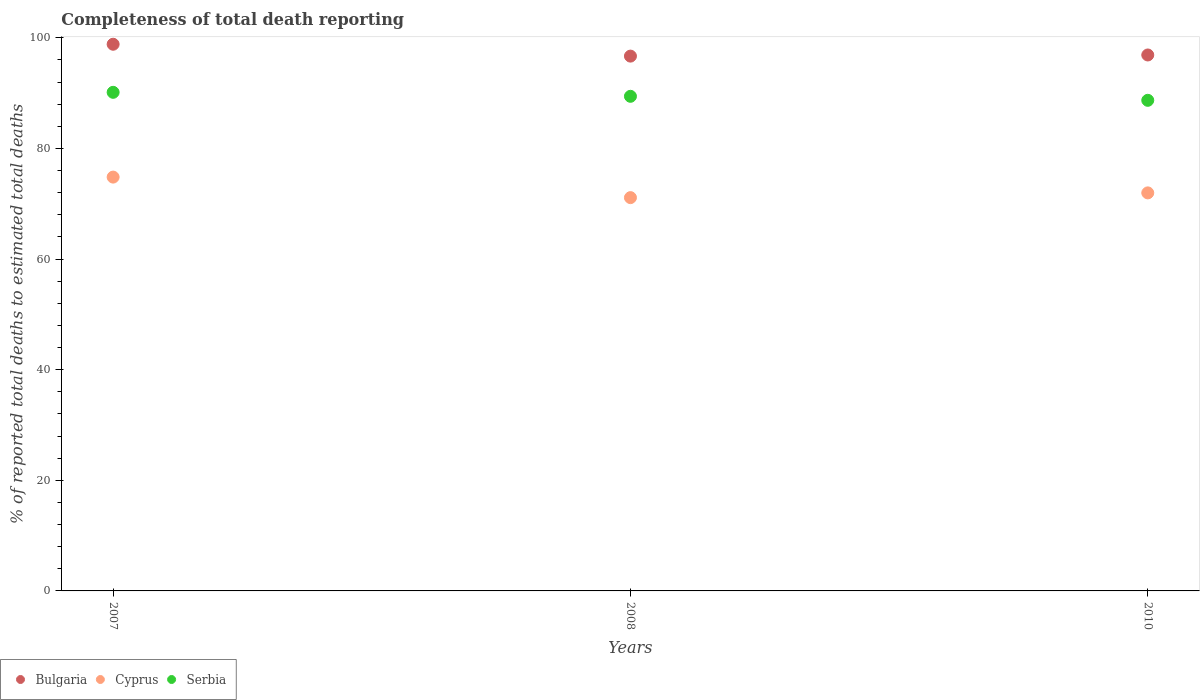What is the percentage of total deaths reported in Bulgaria in 2008?
Provide a succinct answer. 96.7. Across all years, what is the maximum percentage of total deaths reported in Cyprus?
Offer a very short reply. 74.82. Across all years, what is the minimum percentage of total deaths reported in Serbia?
Provide a short and direct response. 88.71. In which year was the percentage of total deaths reported in Bulgaria minimum?
Provide a succinct answer. 2008. What is the total percentage of total deaths reported in Bulgaria in the graph?
Your answer should be very brief. 292.45. What is the difference between the percentage of total deaths reported in Serbia in 2007 and that in 2010?
Your answer should be compact. 1.45. What is the difference between the percentage of total deaths reported in Bulgaria in 2010 and the percentage of total deaths reported in Cyprus in 2008?
Offer a very short reply. 25.79. What is the average percentage of total deaths reported in Serbia per year?
Your response must be concise. 89.43. In the year 2010, what is the difference between the percentage of total deaths reported in Bulgaria and percentage of total deaths reported in Serbia?
Your response must be concise. 8.2. What is the ratio of the percentage of total deaths reported in Bulgaria in 2007 to that in 2008?
Make the answer very short. 1.02. What is the difference between the highest and the second highest percentage of total deaths reported in Serbia?
Offer a very short reply. 0.72. What is the difference between the highest and the lowest percentage of total deaths reported in Cyprus?
Provide a succinct answer. 3.71. In how many years, is the percentage of total deaths reported in Serbia greater than the average percentage of total deaths reported in Serbia taken over all years?
Your answer should be very brief. 2. Is the percentage of total deaths reported in Cyprus strictly greater than the percentage of total deaths reported in Bulgaria over the years?
Ensure brevity in your answer.  No. How many dotlines are there?
Your response must be concise. 3. Does the graph contain any zero values?
Make the answer very short. No. Does the graph contain grids?
Make the answer very short. No. How many legend labels are there?
Your answer should be compact. 3. What is the title of the graph?
Your answer should be compact. Completeness of total death reporting. What is the label or title of the Y-axis?
Offer a very short reply. % of reported total deaths to estimated total deaths. What is the % of reported total deaths to estimated total deaths of Bulgaria in 2007?
Ensure brevity in your answer.  98.84. What is the % of reported total deaths to estimated total deaths in Cyprus in 2007?
Provide a short and direct response. 74.82. What is the % of reported total deaths to estimated total deaths in Serbia in 2007?
Offer a terse response. 90.15. What is the % of reported total deaths to estimated total deaths of Bulgaria in 2008?
Ensure brevity in your answer.  96.7. What is the % of reported total deaths to estimated total deaths in Cyprus in 2008?
Your answer should be very brief. 71.11. What is the % of reported total deaths to estimated total deaths in Serbia in 2008?
Offer a very short reply. 89.43. What is the % of reported total deaths to estimated total deaths in Bulgaria in 2010?
Keep it short and to the point. 96.9. What is the % of reported total deaths to estimated total deaths of Cyprus in 2010?
Offer a very short reply. 71.97. What is the % of reported total deaths to estimated total deaths in Serbia in 2010?
Your answer should be compact. 88.71. Across all years, what is the maximum % of reported total deaths to estimated total deaths in Bulgaria?
Provide a succinct answer. 98.84. Across all years, what is the maximum % of reported total deaths to estimated total deaths of Cyprus?
Provide a succinct answer. 74.82. Across all years, what is the maximum % of reported total deaths to estimated total deaths in Serbia?
Keep it short and to the point. 90.15. Across all years, what is the minimum % of reported total deaths to estimated total deaths in Bulgaria?
Offer a very short reply. 96.7. Across all years, what is the minimum % of reported total deaths to estimated total deaths of Cyprus?
Ensure brevity in your answer.  71.11. Across all years, what is the minimum % of reported total deaths to estimated total deaths in Serbia?
Provide a succinct answer. 88.71. What is the total % of reported total deaths to estimated total deaths in Bulgaria in the graph?
Your answer should be very brief. 292.45. What is the total % of reported total deaths to estimated total deaths of Cyprus in the graph?
Keep it short and to the point. 217.9. What is the total % of reported total deaths to estimated total deaths in Serbia in the graph?
Your answer should be compact. 268.29. What is the difference between the % of reported total deaths to estimated total deaths of Bulgaria in 2007 and that in 2008?
Your answer should be very brief. 2.15. What is the difference between the % of reported total deaths to estimated total deaths in Cyprus in 2007 and that in 2008?
Give a very brief answer. 3.71. What is the difference between the % of reported total deaths to estimated total deaths in Serbia in 2007 and that in 2008?
Give a very brief answer. 0.72. What is the difference between the % of reported total deaths to estimated total deaths of Bulgaria in 2007 and that in 2010?
Provide a short and direct response. 1.94. What is the difference between the % of reported total deaths to estimated total deaths of Cyprus in 2007 and that in 2010?
Offer a very short reply. 2.85. What is the difference between the % of reported total deaths to estimated total deaths of Serbia in 2007 and that in 2010?
Provide a short and direct response. 1.45. What is the difference between the % of reported total deaths to estimated total deaths in Bulgaria in 2008 and that in 2010?
Provide a short and direct response. -0.21. What is the difference between the % of reported total deaths to estimated total deaths of Cyprus in 2008 and that in 2010?
Give a very brief answer. -0.86. What is the difference between the % of reported total deaths to estimated total deaths in Serbia in 2008 and that in 2010?
Make the answer very short. 0.73. What is the difference between the % of reported total deaths to estimated total deaths of Bulgaria in 2007 and the % of reported total deaths to estimated total deaths of Cyprus in 2008?
Offer a terse response. 27.73. What is the difference between the % of reported total deaths to estimated total deaths of Bulgaria in 2007 and the % of reported total deaths to estimated total deaths of Serbia in 2008?
Provide a succinct answer. 9.41. What is the difference between the % of reported total deaths to estimated total deaths of Cyprus in 2007 and the % of reported total deaths to estimated total deaths of Serbia in 2008?
Your answer should be compact. -14.61. What is the difference between the % of reported total deaths to estimated total deaths in Bulgaria in 2007 and the % of reported total deaths to estimated total deaths in Cyprus in 2010?
Make the answer very short. 26.87. What is the difference between the % of reported total deaths to estimated total deaths of Bulgaria in 2007 and the % of reported total deaths to estimated total deaths of Serbia in 2010?
Offer a terse response. 10.14. What is the difference between the % of reported total deaths to estimated total deaths in Cyprus in 2007 and the % of reported total deaths to estimated total deaths in Serbia in 2010?
Provide a short and direct response. -13.88. What is the difference between the % of reported total deaths to estimated total deaths in Bulgaria in 2008 and the % of reported total deaths to estimated total deaths in Cyprus in 2010?
Keep it short and to the point. 24.73. What is the difference between the % of reported total deaths to estimated total deaths in Bulgaria in 2008 and the % of reported total deaths to estimated total deaths in Serbia in 2010?
Your answer should be very brief. 7.99. What is the difference between the % of reported total deaths to estimated total deaths of Cyprus in 2008 and the % of reported total deaths to estimated total deaths of Serbia in 2010?
Ensure brevity in your answer.  -17.59. What is the average % of reported total deaths to estimated total deaths in Bulgaria per year?
Your response must be concise. 97.48. What is the average % of reported total deaths to estimated total deaths in Cyprus per year?
Give a very brief answer. 72.64. What is the average % of reported total deaths to estimated total deaths in Serbia per year?
Give a very brief answer. 89.43. In the year 2007, what is the difference between the % of reported total deaths to estimated total deaths in Bulgaria and % of reported total deaths to estimated total deaths in Cyprus?
Your answer should be very brief. 24.02. In the year 2007, what is the difference between the % of reported total deaths to estimated total deaths of Bulgaria and % of reported total deaths to estimated total deaths of Serbia?
Make the answer very short. 8.69. In the year 2007, what is the difference between the % of reported total deaths to estimated total deaths in Cyprus and % of reported total deaths to estimated total deaths in Serbia?
Keep it short and to the point. -15.33. In the year 2008, what is the difference between the % of reported total deaths to estimated total deaths in Bulgaria and % of reported total deaths to estimated total deaths in Cyprus?
Provide a short and direct response. 25.59. In the year 2008, what is the difference between the % of reported total deaths to estimated total deaths of Bulgaria and % of reported total deaths to estimated total deaths of Serbia?
Provide a succinct answer. 7.27. In the year 2008, what is the difference between the % of reported total deaths to estimated total deaths of Cyprus and % of reported total deaths to estimated total deaths of Serbia?
Your response must be concise. -18.32. In the year 2010, what is the difference between the % of reported total deaths to estimated total deaths in Bulgaria and % of reported total deaths to estimated total deaths in Cyprus?
Provide a short and direct response. 24.93. In the year 2010, what is the difference between the % of reported total deaths to estimated total deaths in Bulgaria and % of reported total deaths to estimated total deaths in Serbia?
Provide a short and direct response. 8.2. In the year 2010, what is the difference between the % of reported total deaths to estimated total deaths in Cyprus and % of reported total deaths to estimated total deaths in Serbia?
Give a very brief answer. -16.74. What is the ratio of the % of reported total deaths to estimated total deaths in Bulgaria in 2007 to that in 2008?
Keep it short and to the point. 1.02. What is the ratio of the % of reported total deaths to estimated total deaths in Cyprus in 2007 to that in 2008?
Provide a short and direct response. 1.05. What is the ratio of the % of reported total deaths to estimated total deaths of Bulgaria in 2007 to that in 2010?
Your answer should be very brief. 1.02. What is the ratio of the % of reported total deaths to estimated total deaths in Cyprus in 2007 to that in 2010?
Make the answer very short. 1.04. What is the ratio of the % of reported total deaths to estimated total deaths in Serbia in 2007 to that in 2010?
Make the answer very short. 1.02. What is the ratio of the % of reported total deaths to estimated total deaths in Bulgaria in 2008 to that in 2010?
Keep it short and to the point. 1. What is the ratio of the % of reported total deaths to estimated total deaths of Serbia in 2008 to that in 2010?
Ensure brevity in your answer.  1.01. What is the difference between the highest and the second highest % of reported total deaths to estimated total deaths in Bulgaria?
Your answer should be compact. 1.94. What is the difference between the highest and the second highest % of reported total deaths to estimated total deaths in Cyprus?
Give a very brief answer. 2.85. What is the difference between the highest and the second highest % of reported total deaths to estimated total deaths in Serbia?
Your answer should be compact. 0.72. What is the difference between the highest and the lowest % of reported total deaths to estimated total deaths of Bulgaria?
Make the answer very short. 2.15. What is the difference between the highest and the lowest % of reported total deaths to estimated total deaths in Cyprus?
Offer a terse response. 3.71. What is the difference between the highest and the lowest % of reported total deaths to estimated total deaths of Serbia?
Provide a short and direct response. 1.45. 